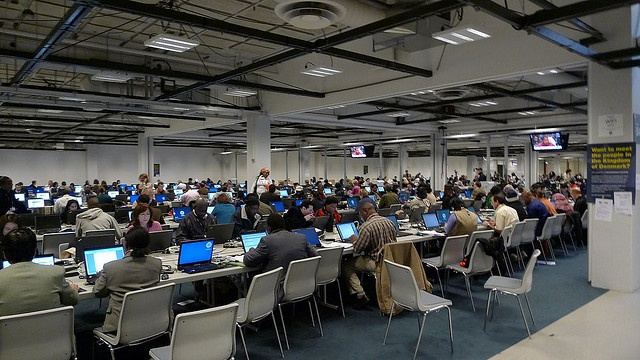Describe the objects in this image and their specific colors. I can see people in black, gray, and darkgray tones, laptop in black, gray, white, and darkgray tones, chair in black, gray, and purple tones, chair in black, gray, and lightgray tones, and chair in black, gray, and darkgray tones in this image. 